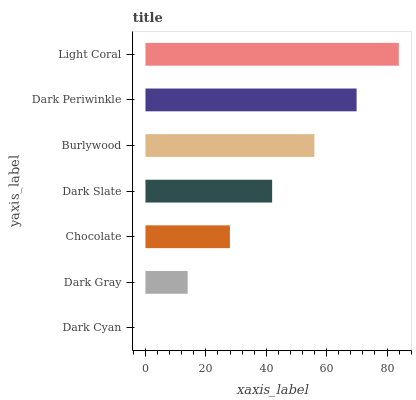Is Dark Cyan the minimum?
Answer yes or no. Yes. Is Light Coral the maximum?
Answer yes or no. Yes. Is Dark Gray the minimum?
Answer yes or no. No. Is Dark Gray the maximum?
Answer yes or no. No. Is Dark Gray greater than Dark Cyan?
Answer yes or no. Yes. Is Dark Cyan less than Dark Gray?
Answer yes or no. Yes. Is Dark Cyan greater than Dark Gray?
Answer yes or no. No. Is Dark Gray less than Dark Cyan?
Answer yes or no. No. Is Dark Slate the high median?
Answer yes or no. Yes. Is Dark Slate the low median?
Answer yes or no. Yes. Is Chocolate the high median?
Answer yes or no. No. Is Dark Periwinkle the low median?
Answer yes or no. No. 